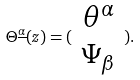<formula> <loc_0><loc_0><loc_500><loc_500>\Theta ^ { \underline { \alpha } } ( z ) = ( \begin{array} { c } \theta ^ { \alpha } \\ \Psi _ { \beta } \end{array} ) .</formula> 